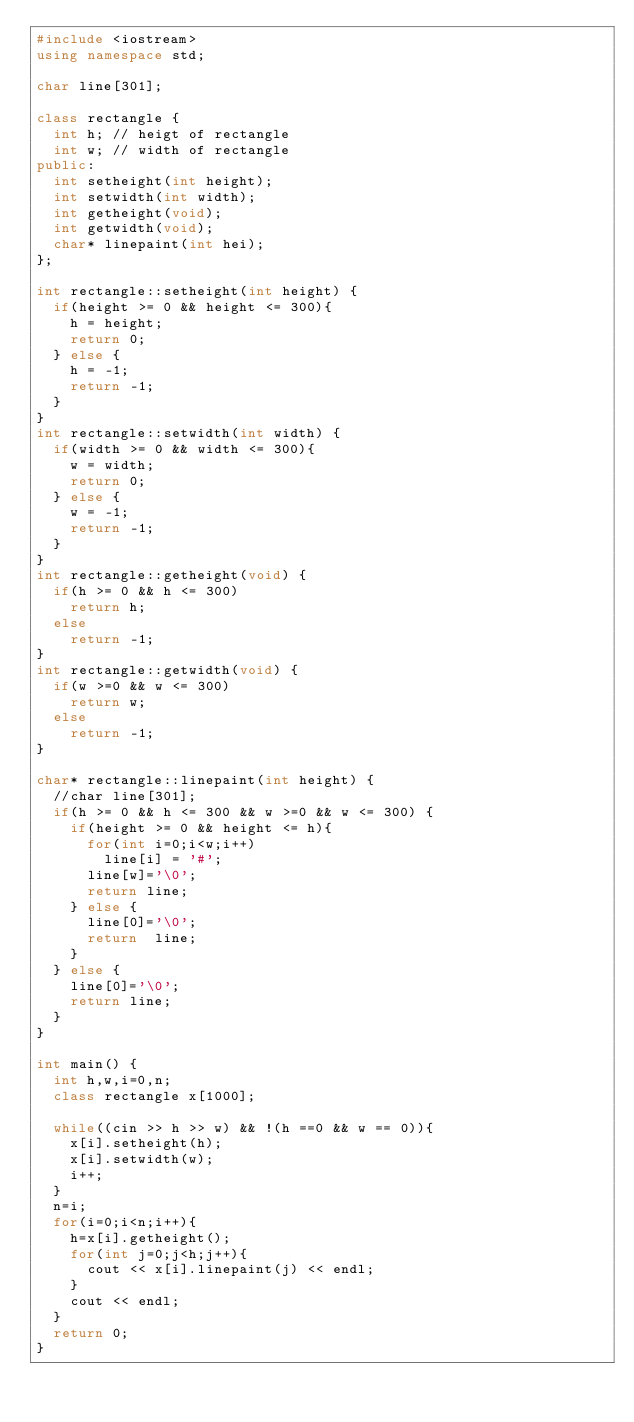Convert code to text. <code><loc_0><loc_0><loc_500><loc_500><_C++_>#include <iostream>
using namespace std;

char line[301];

class rectangle {
	int h; // heigt of rectangle
	int w; // width of rectangle
public:
	int setheight(int height);
	int setwidth(int width);
	int getheight(void);
	int getwidth(void);
	char* linepaint(int hei);
};

int rectangle::setheight(int height) {
	if(height >= 0 && height <= 300){
		h = height;
		return 0;
	} else {
		h = -1;
		return -1;
	}
}
int rectangle::setwidth(int width) {
	if(width >= 0 && width <= 300){
		w = width;
		return 0;
	} else {
		w = -1;
		return -1;
	}
}
int rectangle::getheight(void) {
	if(h >= 0 && h <= 300)
		return h;
	else
		return -1;
}
int rectangle::getwidth(void) {
	if(w >=0 && w <= 300)
		return w;
	else
		return -1;
}

char* rectangle::linepaint(int height) {
	//char line[301];
	if(h >= 0 && h <= 300 && w >=0 && w <= 300) {
		if(height >= 0 && height <= h){
			for(int i=0;i<w;i++)
				line[i] = '#';
			line[w]='\0';
			return line;
		} else {
			line[0]='\0';
			return  line;
		}
	} else {
		line[0]='\0';
		return line;
	}
}

int main() {
	int h,w,i=0,n;
	class rectangle x[1000];

	while((cin >> h >> w) && !(h ==0 && w == 0)){
		x[i].setheight(h);
		x[i].setwidth(w);
		i++;
	}
	n=i;
	for(i=0;i<n;i++){
		h=x[i].getheight();
		for(int j=0;j<h;j++){
			cout << x[i].linepaint(j) << endl;
		}
		cout << endl;
	}
	return 0;
}

</code> 